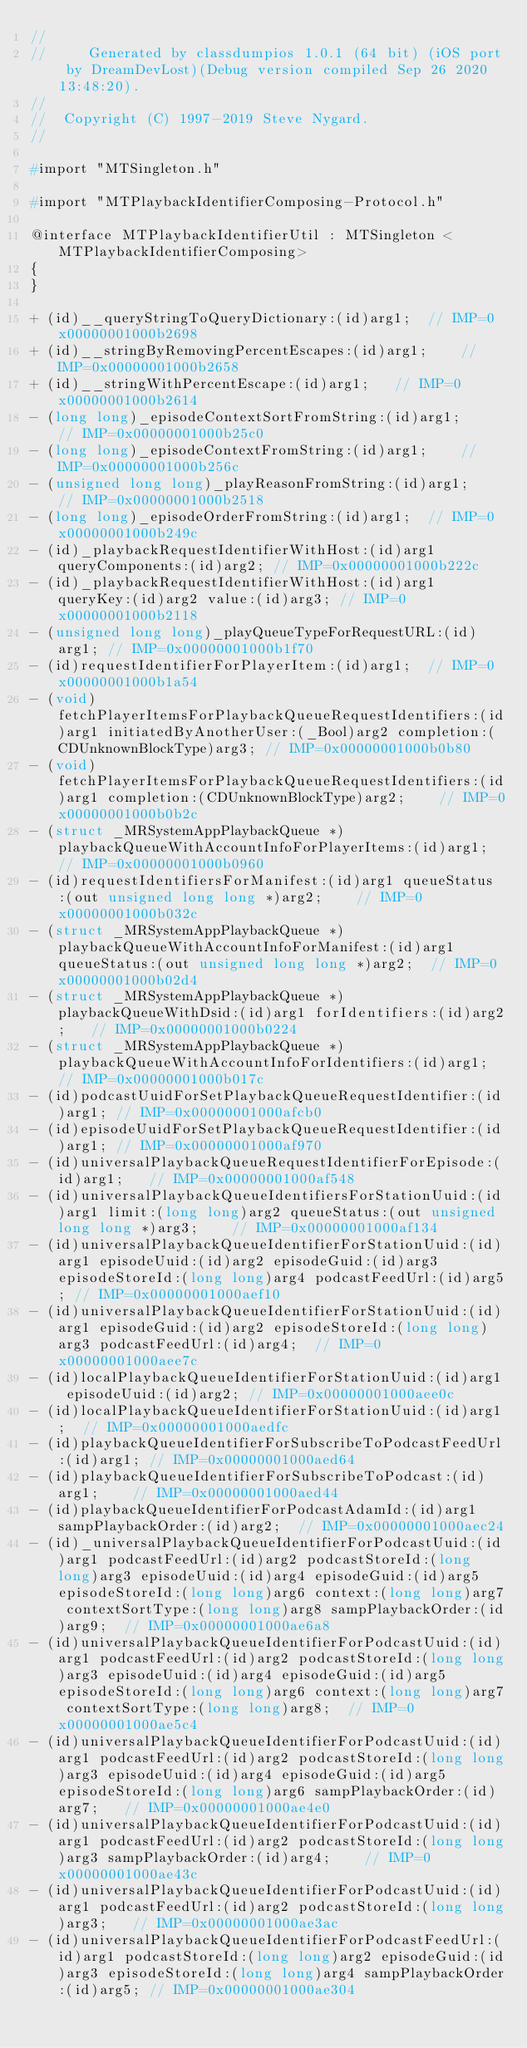<code> <loc_0><loc_0><loc_500><loc_500><_C_>//
//     Generated by classdumpios 1.0.1 (64 bit) (iOS port by DreamDevLost)(Debug version compiled Sep 26 2020 13:48:20).
//
//  Copyright (C) 1997-2019 Steve Nygard.
//

#import "MTSingleton.h"

#import "MTPlaybackIdentifierComposing-Protocol.h"

@interface MTPlaybackIdentifierUtil : MTSingleton <MTPlaybackIdentifierComposing>
{
}

+ (id)__queryStringToQueryDictionary:(id)arg1;	// IMP=0x00000001000b2698
+ (id)__stringByRemovingPercentEscapes:(id)arg1;	// IMP=0x00000001000b2658
+ (id)__stringWithPercentEscape:(id)arg1;	// IMP=0x00000001000b2614
- (long long)_episodeContextSortFromString:(id)arg1;	// IMP=0x00000001000b25c0
- (long long)_episodeContextFromString:(id)arg1;	// IMP=0x00000001000b256c
- (unsigned long long)_playReasonFromString:(id)arg1;	// IMP=0x00000001000b2518
- (long long)_episodeOrderFromString:(id)arg1;	// IMP=0x00000001000b249c
- (id)_playbackRequestIdentifierWithHost:(id)arg1 queryComponents:(id)arg2;	// IMP=0x00000001000b222c
- (id)_playbackRequestIdentifierWithHost:(id)arg1 queryKey:(id)arg2 value:(id)arg3;	// IMP=0x00000001000b2118
- (unsigned long long)_playQueueTypeForRequestURL:(id)arg1;	// IMP=0x00000001000b1f70
- (id)requestIdentifierForPlayerItem:(id)arg1;	// IMP=0x00000001000b1a54
- (void)fetchPlayerItemsForPlaybackQueueRequestIdentifiers:(id)arg1 initiatedByAnotherUser:(_Bool)arg2 completion:(CDUnknownBlockType)arg3;	// IMP=0x00000001000b0b80
- (void)fetchPlayerItemsForPlaybackQueueRequestIdentifiers:(id)arg1 completion:(CDUnknownBlockType)arg2;	// IMP=0x00000001000b0b2c
- (struct _MRSystemAppPlaybackQueue *)playbackQueueWithAccountInfoForPlayerItems:(id)arg1;	// IMP=0x00000001000b0960
- (id)requestIdentifiersForManifest:(id)arg1 queueStatus:(out unsigned long long *)arg2;	// IMP=0x00000001000b032c
- (struct _MRSystemAppPlaybackQueue *)playbackQueueWithAccountInfoForManifest:(id)arg1 queueStatus:(out unsigned long long *)arg2;	// IMP=0x00000001000b02d4
- (struct _MRSystemAppPlaybackQueue *)playbackQueueWithDsid:(id)arg1 forIdentifiers:(id)arg2;	// IMP=0x00000001000b0224
- (struct _MRSystemAppPlaybackQueue *)playbackQueueWithAccountInfoForIdentifiers:(id)arg1;	// IMP=0x00000001000b017c
- (id)podcastUuidForSetPlaybackQueueRequestIdentifier:(id)arg1;	// IMP=0x00000001000afcb0
- (id)episodeUuidForSetPlaybackQueueRequestIdentifier:(id)arg1;	// IMP=0x00000001000af970
- (id)universalPlaybackQueueRequestIdentifierForEpisode:(id)arg1;	// IMP=0x00000001000af548
- (id)universalPlaybackQueueIdentifiersForStationUuid:(id)arg1 limit:(long long)arg2 queueStatus:(out unsigned long long *)arg3;	// IMP=0x00000001000af134
- (id)universalPlaybackQueueIdentifierForStationUuid:(id)arg1 episodeUuid:(id)arg2 episodeGuid:(id)arg3 episodeStoreId:(long long)arg4 podcastFeedUrl:(id)arg5;	// IMP=0x00000001000aef10
- (id)universalPlaybackQueueIdentifierForStationUuid:(id)arg1 episodeGuid:(id)arg2 episodeStoreId:(long long)arg3 podcastFeedUrl:(id)arg4;	// IMP=0x00000001000aee7c
- (id)localPlaybackQueueIdentifierForStationUuid:(id)arg1 episodeUuid:(id)arg2;	// IMP=0x00000001000aee0c
- (id)localPlaybackQueueIdentifierForStationUuid:(id)arg1;	// IMP=0x00000001000aedfc
- (id)playbackQueueIdentifierForSubscribeToPodcastFeedUrl:(id)arg1;	// IMP=0x00000001000aed64
- (id)playbackQueueIdentifierForSubscribeToPodcast:(id)arg1;	// IMP=0x00000001000aed44
- (id)playbackQueueIdentifierForPodcastAdamId:(id)arg1 sampPlaybackOrder:(id)arg2;	// IMP=0x00000001000aec24
- (id)_universalPlaybackQueueIdentifierForPodcastUuid:(id)arg1 podcastFeedUrl:(id)arg2 podcastStoreId:(long long)arg3 episodeUuid:(id)arg4 episodeGuid:(id)arg5 episodeStoreId:(long long)arg6 context:(long long)arg7 contextSortType:(long long)arg8 sampPlaybackOrder:(id)arg9;	// IMP=0x00000001000ae6a8
- (id)universalPlaybackQueueIdentifierForPodcastUuid:(id)arg1 podcastFeedUrl:(id)arg2 podcastStoreId:(long long)arg3 episodeUuid:(id)arg4 episodeGuid:(id)arg5 episodeStoreId:(long long)arg6 context:(long long)arg7 contextSortType:(long long)arg8;	// IMP=0x00000001000ae5c4
- (id)universalPlaybackQueueIdentifierForPodcastUuid:(id)arg1 podcastFeedUrl:(id)arg2 podcastStoreId:(long long)arg3 episodeUuid:(id)arg4 episodeGuid:(id)arg5 episodeStoreId:(long long)arg6 sampPlaybackOrder:(id)arg7;	// IMP=0x00000001000ae4e0
- (id)universalPlaybackQueueIdentifierForPodcastUuid:(id)arg1 podcastFeedUrl:(id)arg2 podcastStoreId:(long long)arg3 sampPlaybackOrder:(id)arg4;	// IMP=0x00000001000ae43c
- (id)universalPlaybackQueueIdentifierForPodcastUuid:(id)arg1 podcastFeedUrl:(id)arg2 podcastStoreId:(long long)arg3;	// IMP=0x00000001000ae3ac
- (id)universalPlaybackQueueIdentifierForPodcastFeedUrl:(id)arg1 podcastStoreId:(long long)arg2 episodeGuid:(id)arg3 episodeStoreId:(long long)arg4 sampPlaybackOrder:(id)arg5;	// IMP=0x00000001000ae304</code> 